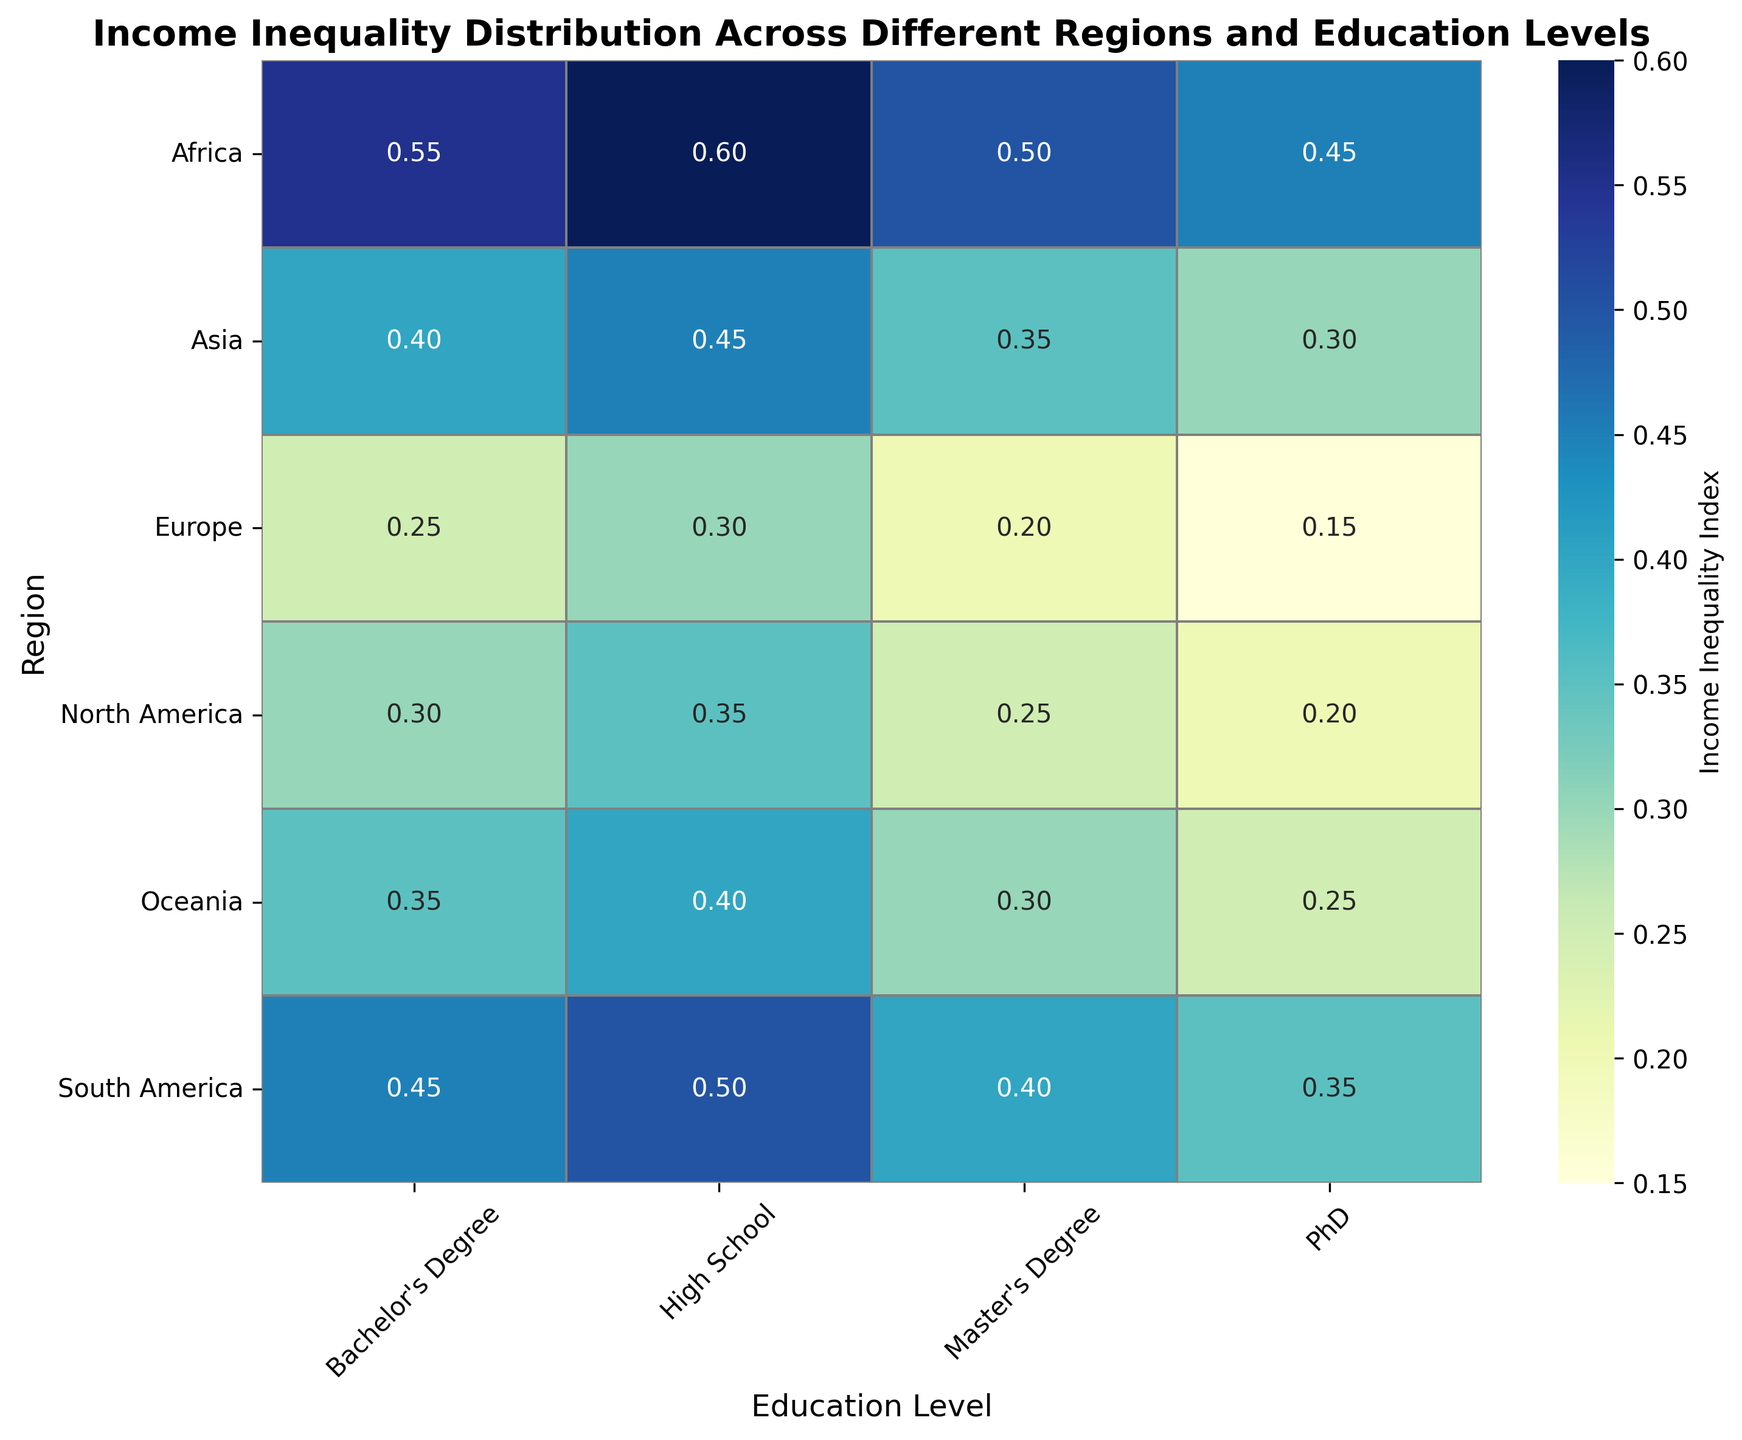What region has the lowest income inequality index at the PhD level? To find the region with the lowest income inequality index at the PhD level, look at the row for PhD in the heatmap and identify the cell with the smallest value.
Answer: Europe Which region and education level combination shows the highest income inequality index? Look for the darkest cell in the heatmap, as darker colors represent higher income inequality indices. Identify both the region and the education level for this cell.
Answer: Africa, High School How does the income inequality index for North America with a Bachelor's degree compare to that of Asia with a Bachelor's degree? Locate the values for North America and Asia in the Bachelor's degree column. Compare the numbers, noting that the lower the value, the lesser the income inequality.
Answer: North America is lower than Asia What is the average income inequality index for Europe across all education levels? Add the income inequality indices for Europe across all education levels and divide by the number of education levels (4): (0.30 + 0.25 + 0.20 + 0.15) / 4 = 0.225.
Answer: 0.225 If you sum the income inequality indices for Oceania across all education levels, what is the result? Add the values of the income inequality indices for Oceania across all education levels: 0.40 + 0.35 + 0.30 + 0.25.
Answer: 1.30 Compare the income inequality index at the Master's degree level between South America and Africa. Which region has a lower index? Locate the Master's degree row for South America and Africa, compare the values directly to see which is lower.
Answer: South America Which education level shows the most consistent range of income inequality indices across different regions? Examine the columns for each education level and note the range of values. The smallest range across regions indicates the most consistent level.
Answer: PhD What is the difference in income inequality index between Africa and Europe at the High School level? Subtract Europe's High School income inequality index from Africa's: 0.60 - 0.30 = 0.30.
Answer: 0.30 